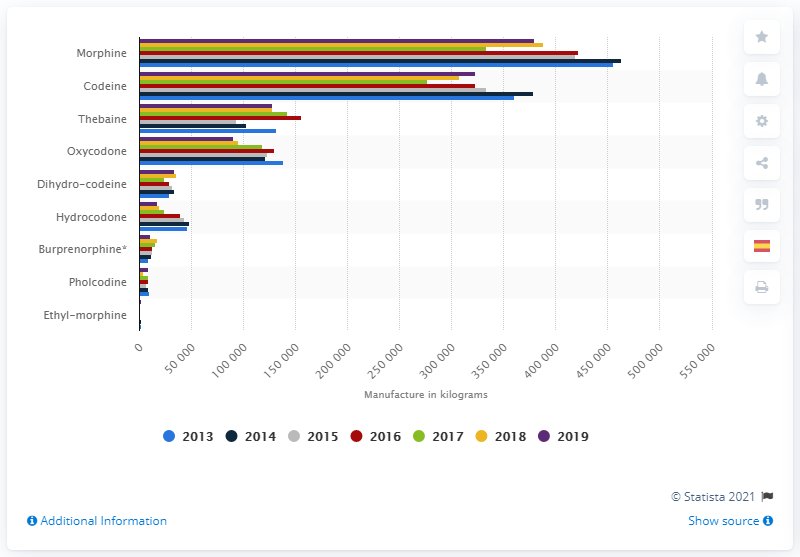Draw attention to some important aspects in this diagram. The amount of morphine manufactured worldwide in 2019 was approximately 380,050 metric tons. 